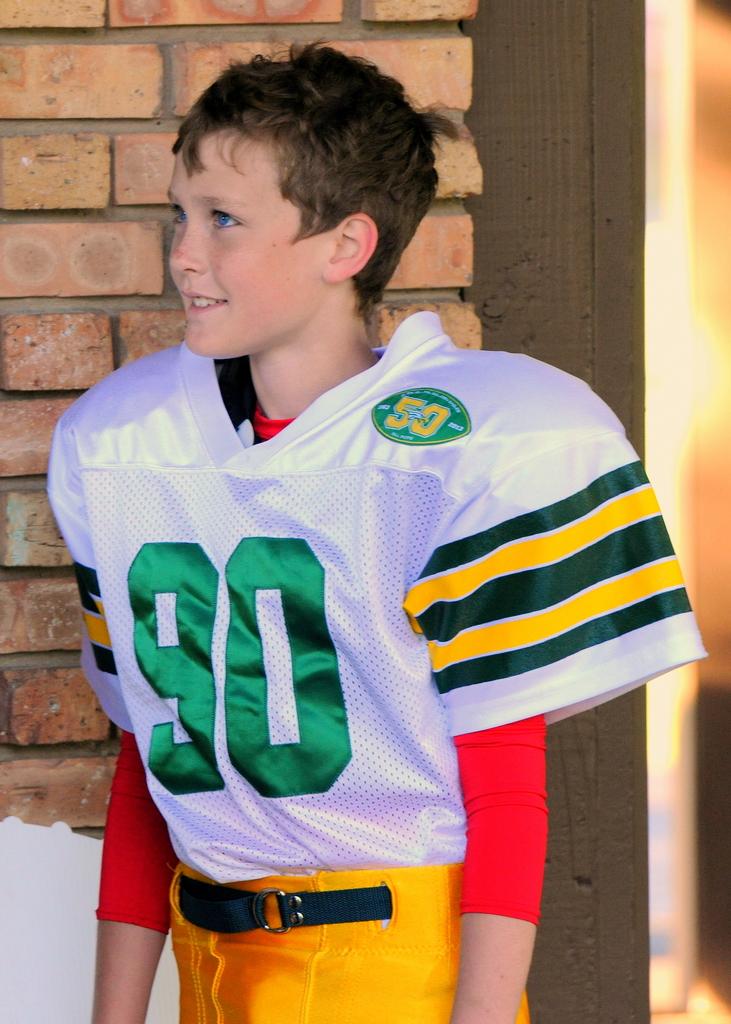What is the player's number?
Your answer should be very brief. 90. What is on the shoulder patch?
Provide a short and direct response. 50. 